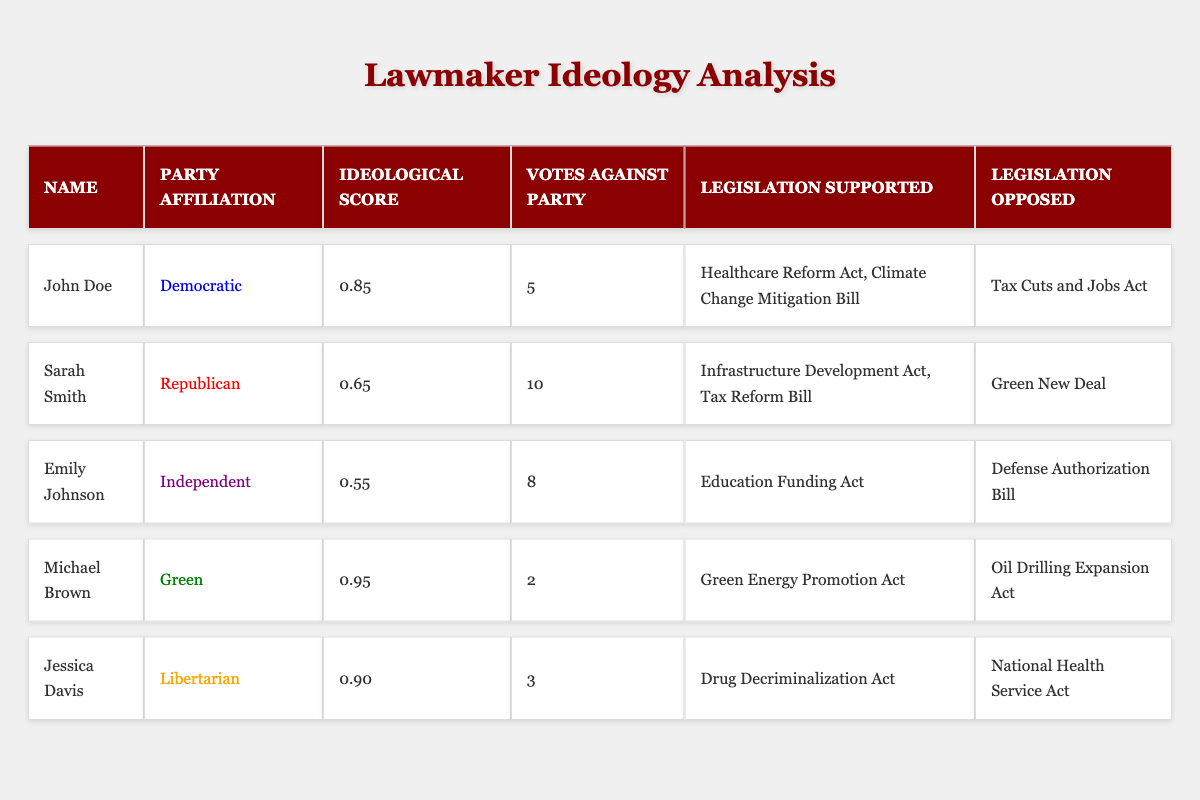What is the ideological score of John Doe? The table shows that John Doe has an ideological score listed under his name. According to the data, this score is 0.85.
Answer: 0.85 How many votes against party did Sarah Smith have? By examining Sarah Smith's row in the table, we see that the number of votes against her party affiliation is stated as 10.
Answer: 10 Which legislation did Emily Johnson support? The table provides a list of legislation supported by Emily Johnson, which includes the "Education Funding Act."
Answer: Education Funding Act Is Michael Brown a member of the Democratic Party? In the table, Michael Brown is clearly identified under the "Party Affiliation" column as belonging to the Green Party, not the Democratic Party.
Answer: No What is the average ideological score of all lawmakers in the table? To calculate the average ideological score, sum the scores of all lawmakers: 0.85 + 0.65 + 0.55 + 0.95 + 0.90 = 4.90. There are 5 lawmakers, so the average is 4.90 / 5 = 0.98.
Answer: 0.98 Who opposed the Tax Cuts and Jobs Act? The table shows that among the lawmakers, John Doe is the only one who opposed the Tax Cuts and Jobs Act, as indicated in his row under "Legislation Opposed."
Answer: John Doe Which party had the lowest ideological score? By comparing the ideological scores of all the lawmakers in the table, we see that Emily Johnson, who is Independent, has the lowest score of 0.55.
Answer: Independent How many total pieces of legislation did Jessica Davis support? The table states that Jessica Davis supported one piece of legislation: the "Drug Decriminalization Act," so she has a total of one supported legislation.
Answer: 1 Are there any lawmakers who voted against their party fewer than three times? Looking at the "Votes Against Party" column, we see that only Michael Brown voted against his party 2 times, making him the only lawmaker with fewer than three votes against his party.
Answer: Yes Which lawmaker supported the "Green Energy Promotion Act"? The table indicates that Michael Brown, who belongs to the Green Party, supported the "Green Energy Promotion Act," as listed in his row under "Legislation Supported."
Answer: Michael Brown What is the difference in votes against party between John Doe and Jessica Davis? John Doe has 5 votes against his party, while Jessica Davis has 3. The difference is calculated as 5 - 3 = 2.
Answer: 2 